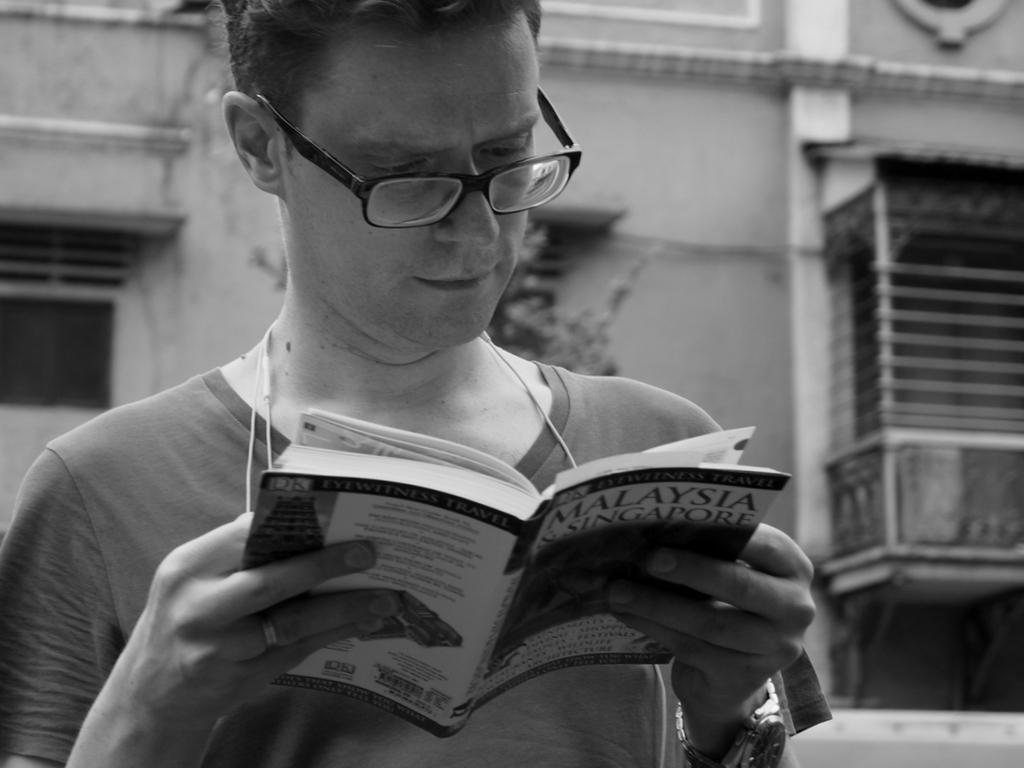What is the person in the image doing? The person is reading a book. What accessories is the person wearing? The person is wearing glasses and a wristwatch. What can be seen in the background of the image? There is a building and windows visible in the background of the image. What color is the shirt the person is wearing in the image? The provided facts do not mention the color or type of shirt the person is wearing. 